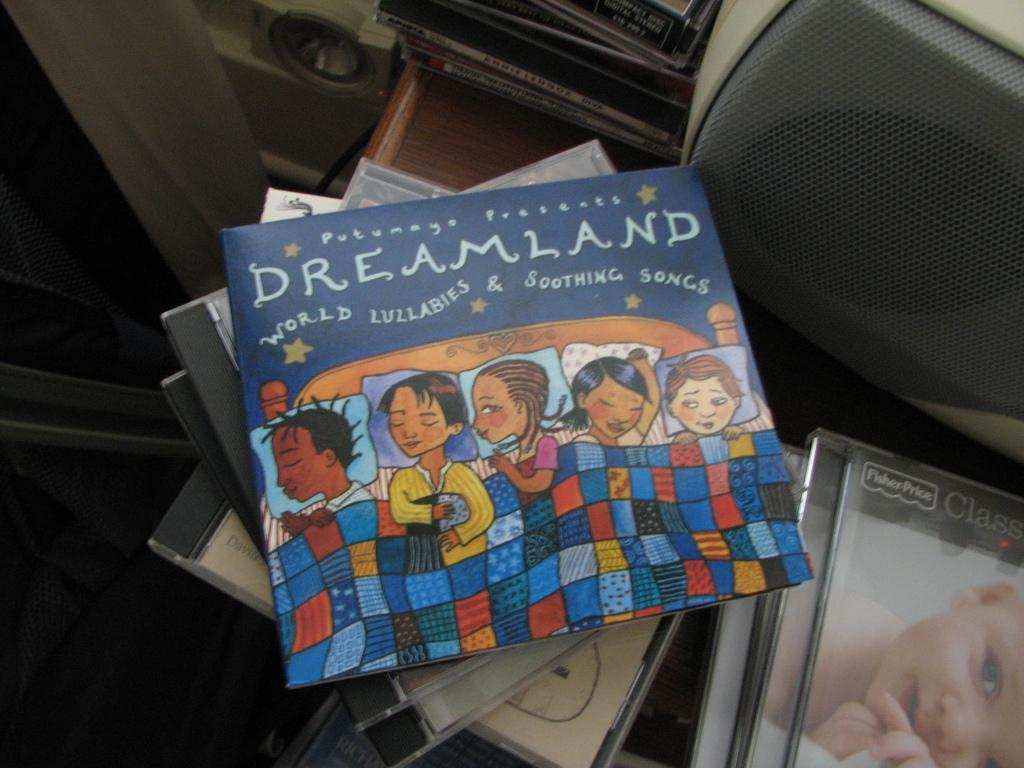What type of electronic devices are present in the image? There are speakers in the image. Can you describe any other objects visible in the image? There are other objects in the image, but their specific details are not mentioned in the provided facts. Is there a gate visible in the image? There is no mention of a gate in the provided facts, so it cannot be determined if one is present in the image. 